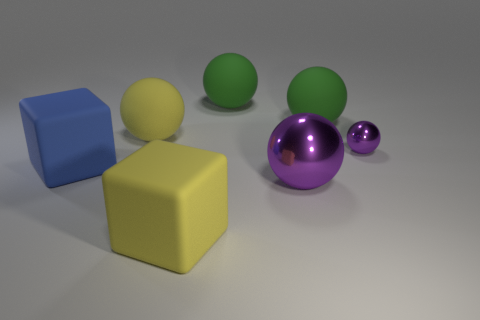Subtract all yellow matte balls. How many balls are left? 4 Add 2 blue rubber blocks. How many objects exist? 9 Subtract all purple balls. How many balls are left? 3 Subtract all spheres. How many objects are left? 2 Subtract 4 balls. How many balls are left? 1 Subtract all purple metal balls. Subtract all small gray cylinders. How many objects are left? 5 Add 3 large spheres. How many large spheres are left? 7 Add 2 large yellow cubes. How many large yellow cubes exist? 3 Subtract 0 gray cylinders. How many objects are left? 7 Subtract all gray spheres. Subtract all blue blocks. How many spheres are left? 5 